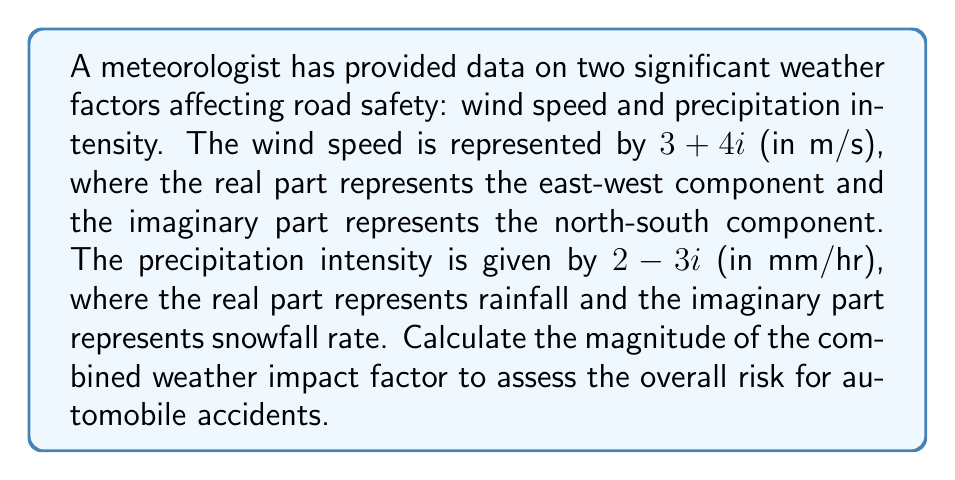Can you solve this math problem? To solve this problem, we'll follow these steps:

1) The combined weather impact factor is the sum of the two complex numbers:
   $$(3 + 4i) + (2 - 3i) = 5 + i$$

2) To find the magnitude of this combined factor, we need to calculate its absolute value. For a complex number $a + bi$, the magnitude is given by $\sqrt{a^2 + b^2}$.

3) In this case, we have $5 + i$, so $a = 5$ and $b = 1$.

4) Let's substitute these values into the formula:
   $$\sqrt{5^2 + 1^2} = \sqrt{25 + 1} = \sqrt{26}$$

5) The square root of 26 cannot be simplified further, so this is our final answer.

This magnitude represents the overall intensity of the weather conditions, combining both wind speed and precipitation, which can be used to assess the risk for automobile accidents.
Answer: $\sqrt{26}$ 